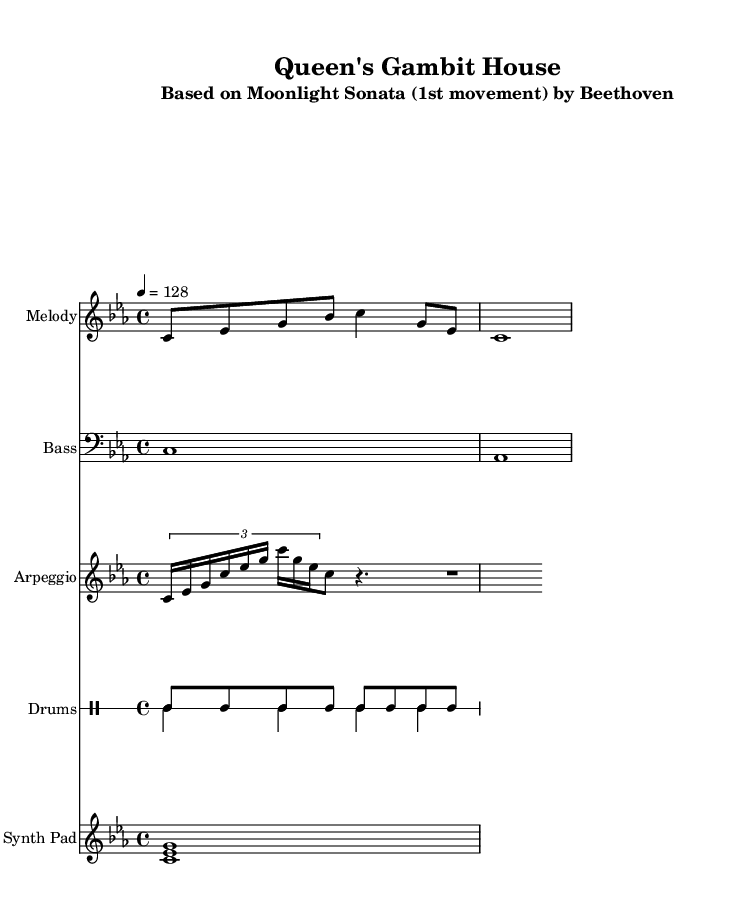What is the key signature of this music? The key signature is C minor, which has three flats (B flat, E flat, and A flat). It can be identified by looking at the key signature located at the beginning of the staff, where the flats are indicated.
Answer: C minor What is the time signature of the piece? The time signature shown is 4/4, which can be observed in the beginning of the score. This means there are four beats in each measure, and the quarter note receives one beat.
Answer: 4/4 What is the tempo marking indicated in the music? The tempo marking is 4 = 128, which is found at the beginning of the score. This indicates that the quarter note is played at a speed of 128 beats per minute.
Answer: 128 What instrument is designated for the melody part? The melody part is for piano, which is indicated by the instrument name shown at the top of the staff along with the respective musical notation for the melody.
Answer: Melody What style of music is this piece referred to? The piece is referred to as "Queen's Gambit House," which is indicated in the title. The term "House" signifies a genre of electronic dance music that typically includes energetic beats and rhythm patterns.
Answer: House What kind of drum pattern is used in this piece? The drum pattern consists of hi-hats in a constant rhythm followed by bass and snare beats, indicated by the specific notation in the drum parts that are showcased in two lines, each showing respective drum patterns.
Answer: Up and down patterns How many voices are in the drum staff? There are two voices in the drum staff, as indicated by the notation showing two separate patterns; one voice for the hi-hats and one for the bass and snare patterns.
Answer: Two voices 